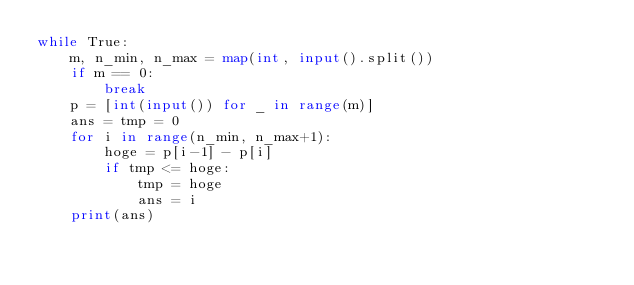Convert code to text. <code><loc_0><loc_0><loc_500><loc_500><_Python_>while True:
    m, n_min, n_max = map(int, input().split())
    if m == 0:
        break
    p = [int(input()) for _ in range(m)]
    ans = tmp = 0
    for i in range(n_min, n_max+1):
        hoge = p[i-1] - p[i]
        if tmp <= hoge:
            tmp = hoge
            ans = i
    print(ans)</code> 